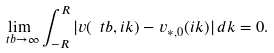<formula> <loc_0><loc_0><loc_500><loc_500>\lim _ { \ t b \to \infty } \int _ { - R } ^ { R } | v ( \ t b , i k ) - v _ { * , 0 } ( i k ) | \, d k = 0 .</formula> 